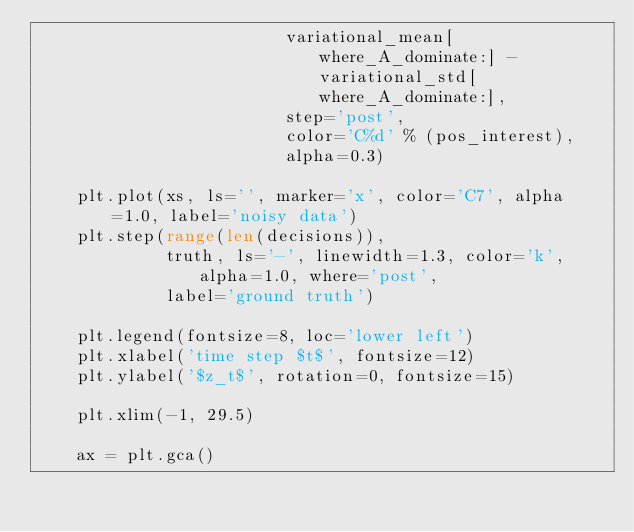<code> <loc_0><loc_0><loc_500><loc_500><_Python_>                         variational_mean[where_A_dominate:] - variational_std[where_A_dominate:],
                         step='post',
                         color='C%d' % (pos_interest),
                         alpha=0.3)

    plt.plot(xs, ls='', marker='x', color='C7', alpha=1.0, label='noisy data')
    plt.step(range(len(decisions)), 
             truth, ls='-', linewidth=1.3, color='k', alpha=1.0, where='post', 
             label='ground truth')

    plt.legend(fontsize=8, loc='lower left')
    plt.xlabel('time step $t$', fontsize=12)
    plt.ylabel('$z_t$', rotation=0, fontsize=15)

    plt.xlim(-1, 29.5)

    ax = plt.gca()</code> 